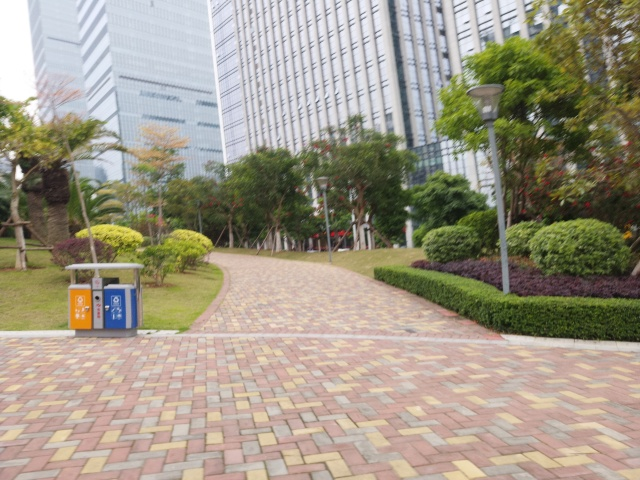What time of day does this image seem to portray? The overcast sky and the lack of strong shadows suggest that it could be either morning or late afternoon, perhaps during a cloudy day that obscures direct sunlight. 